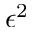Convert formula to latex. <formula><loc_0><loc_0><loc_500><loc_500>\epsilon ^ { 2 }</formula> 